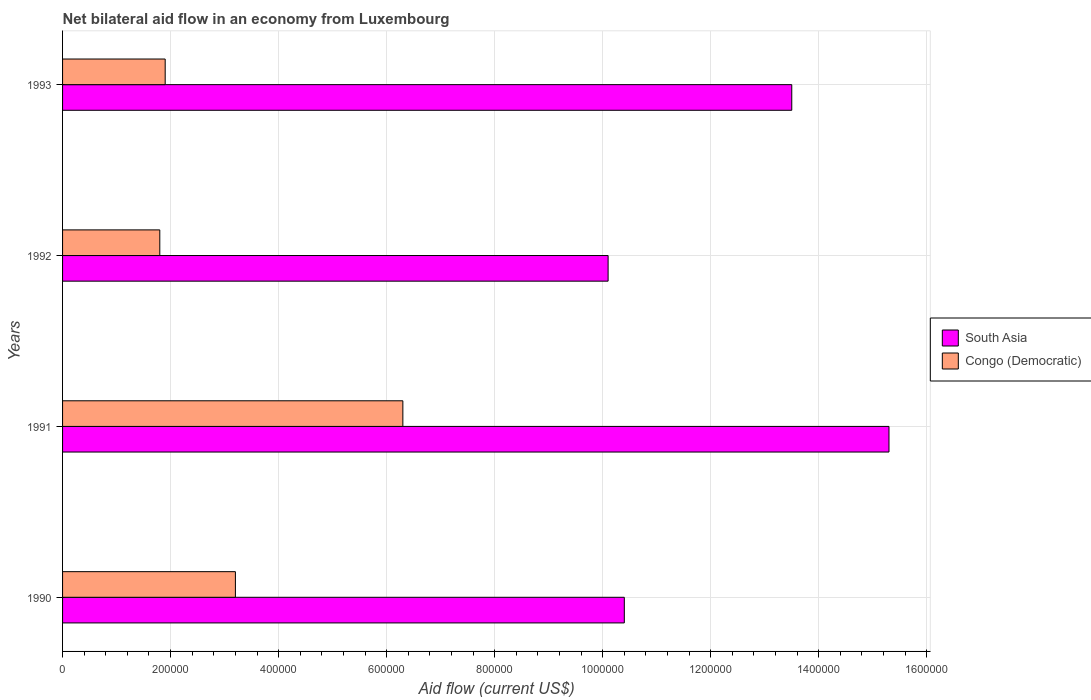Are the number of bars on each tick of the Y-axis equal?
Offer a terse response. Yes. How many bars are there on the 2nd tick from the top?
Ensure brevity in your answer.  2. What is the net bilateral aid flow in South Asia in 1991?
Give a very brief answer. 1.53e+06. Across all years, what is the maximum net bilateral aid flow in South Asia?
Your answer should be compact. 1.53e+06. Across all years, what is the minimum net bilateral aid flow in Congo (Democratic)?
Your answer should be very brief. 1.80e+05. In which year was the net bilateral aid flow in Congo (Democratic) maximum?
Your answer should be very brief. 1991. What is the total net bilateral aid flow in Congo (Democratic) in the graph?
Offer a very short reply. 1.32e+06. What is the difference between the net bilateral aid flow in Congo (Democratic) in 1990 and that in 1992?
Give a very brief answer. 1.40e+05. What is the difference between the net bilateral aid flow in Congo (Democratic) in 1992 and the net bilateral aid flow in South Asia in 1991?
Your response must be concise. -1.35e+06. What is the average net bilateral aid flow in South Asia per year?
Offer a very short reply. 1.23e+06. In the year 1992, what is the difference between the net bilateral aid flow in Congo (Democratic) and net bilateral aid flow in South Asia?
Offer a very short reply. -8.30e+05. What is the ratio of the net bilateral aid flow in South Asia in 1990 to that in 1992?
Offer a very short reply. 1.03. Is the difference between the net bilateral aid flow in Congo (Democratic) in 1991 and 1993 greater than the difference between the net bilateral aid flow in South Asia in 1991 and 1993?
Provide a short and direct response. Yes. What is the difference between the highest and the second highest net bilateral aid flow in Congo (Democratic)?
Your response must be concise. 3.10e+05. What is the difference between the highest and the lowest net bilateral aid flow in South Asia?
Make the answer very short. 5.20e+05. What does the 1st bar from the top in 1993 represents?
Your response must be concise. Congo (Democratic). Are all the bars in the graph horizontal?
Offer a terse response. Yes. What is the difference between two consecutive major ticks on the X-axis?
Keep it short and to the point. 2.00e+05. Are the values on the major ticks of X-axis written in scientific E-notation?
Provide a succinct answer. No. Does the graph contain any zero values?
Ensure brevity in your answer.  No. Does the graph contain grids?
Your response must be concise. Yes. Where does the legend appear in the graph?
Provide a succinct answer. Center right. What is the title of the graph?
Your answer should be very brief. Net bilateral aid flow in an economy from Luxembourg. What is the label or title of the Y-axis?
Give a very brief answer. Years. What is the Aid flow (current US$) of South Asia in 1990?
Your response must be concise. 1.04e+06. What is the Aid flow (current US$) of Congo (Democratic) in 1990?
Offer a very short reply. 3.20e+05. What is the Aid flow (current US$) in South Asia in 1991?
Give a very brief answer. 1.53e+06. What is the Aid flow (current US$) in Congo (Democratic) in 1991?
Provide a succinct answer. 6.30e+05. What is the Aid flow (current US$) of South Asia in 1992?
Keep it short and to the point. 1.01e+06. What is the Aid flow (current US$) in Congo (Democratic) in 1992?
Make the answer very short. 1.80e+05. What is the Aid flow (current US$) of South Asia in 1993?
Give a very brief answer. 1.35e+06. Across all years, what is the maximum Aid flow (current US$) of South Asia?
Keep it short and to the point. 1.53e+06. Across all years, what is the maximum Aid flow (current US$) of Congo (Democratic)?
Give a very brief answer. 6.30e+05. Across all years, what is the minimum Aid flow (current US$) of South Asia?
Ensure brevity in your answer.  1.01e+06. Across all years, what is the minimum Aid flow (current US$) in Congo (Democratic)?
Keep it short and to the point. 1.80e+05. What is the total Aid flow (current US$) in South Asia in the graph?
Your answer should be very brief. 4.93e+06. What is the total Aid flow (current US$) of Congo (Democratic) in the graph?
Offer a terse response. 1.32e+06. What is the difference between the Aid flow (current US$) in South Asia in 1990 and that in 1991?
Offer a terse response. -4.90e+05. What is the difference between the Aid flow (current US$) of Congo (Democratic) in 1990 and that in 1991?
Provide a short and direct response. -3.10e+05. What is the difference between the Aid flow (current US$) in South Asia in 1990 and that in 1993?
Keep it short and to the point. -3.10e+05. What is the difference between the Aid flow (current US$) in Congo (Democratic) in 1990 and that in 1993?
Provide a succinct answer. 1.30e+05. What is the difference between the Aid flow (current US$) in South Asia in 1991 and that in 1992?
Provide a succinct answer. 5.20e+05. What is the difference between the Aid flow (current US$) of Congo (Democratic) in 1991 and that in 1993?
Offer a very short reply. 4.40e+05. What is the difference between the Aid flow (current US$) in South Asia in 1992 and that in 1993?
Your answer should be compact. -3.40e+05. What is the difference between the Aid flow (current US$) in South Asia in 1990 and the Aid flow (current US$) in Congo (Democratic) in 1992?
Give a very brief answer. 8.60e+05. What is the difference between the Aid flow (current US$) in South Asia in 1990 and the Aid flow (current US$) in Congo (Democratic) in 1993?
Keep it short and to the point. 8.50e+05. What is the difference between the Aid flow (current US$) of South Asia in 1991 and the Aid flow (current US$) of Congo (Democratic) in 1992?
Your answer should be very brief. 1.35e+06. What is the difference between the Aid flow (current US$) of South Asia in 1991 and the Aid flow (current US$) of Congo (Democratic) in 1993?
Offer a very short reply. 1.34e+06. What is the difference between the Aid flow (current US$) in South Asia in 1992 and the Aid flow (current US$) in Congo (Democratic) in 1993?
Make the answer very short. 8.20e+05. What is the average Aid flow (current US$) in South Asia per year?
Provide a succinct answer. 1.23e+06. What is the average Aid flow (current US$) in Congo (Democratic) per year?
Make the answer very short. 3.30e+05. In the year 1990, what is the difference between the Aid flow (current US$) of South Asia and Aid flow (current US$) of Congo (Democratic)?
Give a very brief answer. 7.20e+05. In the year 1992, what is the difference between the Aid flow (current US$) in South Asia and Aid flow (current US$) in Congo (Democratic)?
Your answer should be compact. 8.30e+05. In the year 1993, what is the difference between the Aid flow (current US$) of South Asia and Aid flow (current US$) of Congo (Democratic)?
Provide a succinct answer. 1.16e+06. What is the ratio of the Aid flow (current US$) of South Asia in 1990 to that in 1991?
Your response must be concise. 0.68. What is the ratio of the Aid flow (current US$) in Congo (Democratic) in 1990 to that in 1991?
Your answer should be very brief. 0.51. What is the ratio of the Aid flow (current US$) in South Asia in 1990 to that in 1992?
Offer a very short reply. 1.03. What is the ratio of the Aid flow (current US$) of Congo (Democratic) in 1990 to that in 1992?
Keep it short and to the point. 1.78. What is the ratio of the Aid flow (current US$) in South Asia in 1990 to that in 1993?
Provide a succinct answer. 0.77. What is the ratio of the Aid flow (current US$) of Congo (Democratic) in 1990 to that in 1993?
Provide a short and direct response. 1.68. What is the ratio of the Aid flow (current US$) in South Asia in 1991 to that in 1992?
Your answer should be very brief. 1.51. What is the ratio of the Aid flow (current US$) of Congo (Democratic) in 1991 to that in 1992?
Give a very brief answer. 3.5. What is the ratio of the Aid flow (current US$) of South Asia in 1991 to that in 1993?
Provide a short and direct response. 1.13. What is the ratio of the Aid flow (current US$) of Congo (Democratic) in 1991 to that in 1993?
Make the answer very short. 3.32. What is the ratio of the Aid flow (current US$) in South Asia in 1992 to that in 1993?
Provide a succinct answer. 0.75. What is the ratio of the Aid flow (current US$) of Congo (Democratic) in 1992 to that in 1993?
Offer a terse response. 0.95. What is the difference between the highest and the second highest Aid flow (current US$) in Congo (Democratic)?
Your answer should be very brief. 3.10e+05. What is the difference between the highest and the lowest Aid flow (current US$) in South Asia?
Ensure brevity in your answer.  5.20e+05. What is the difference between the highest and the lowest Aid flow (current US$) of Congo (Democratic)?
Provide a short and direct response. 4.50e+05. 